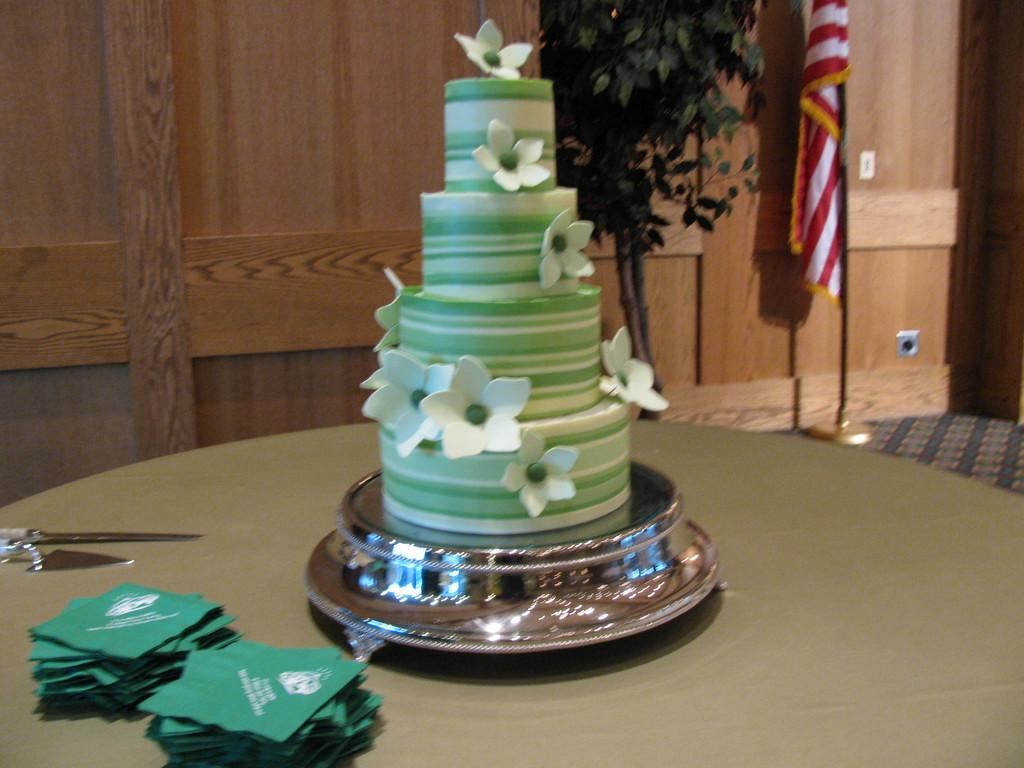What is the main food item in the image? There is a cake in the image. What tool is present in the image that might be used with the cake? There is a knife in the image. What else can be seen on the table in the image? There are other objects on the table. What can be seen in the background of the image? There is a flag and a wall in the background of the image. What type of honey is being drizzled on the cake in the image? There is no honey present in the image; it only shows a cake and a knife on a table. How many daughters are visible in the image? There are no people, including daughters, present in the image. 